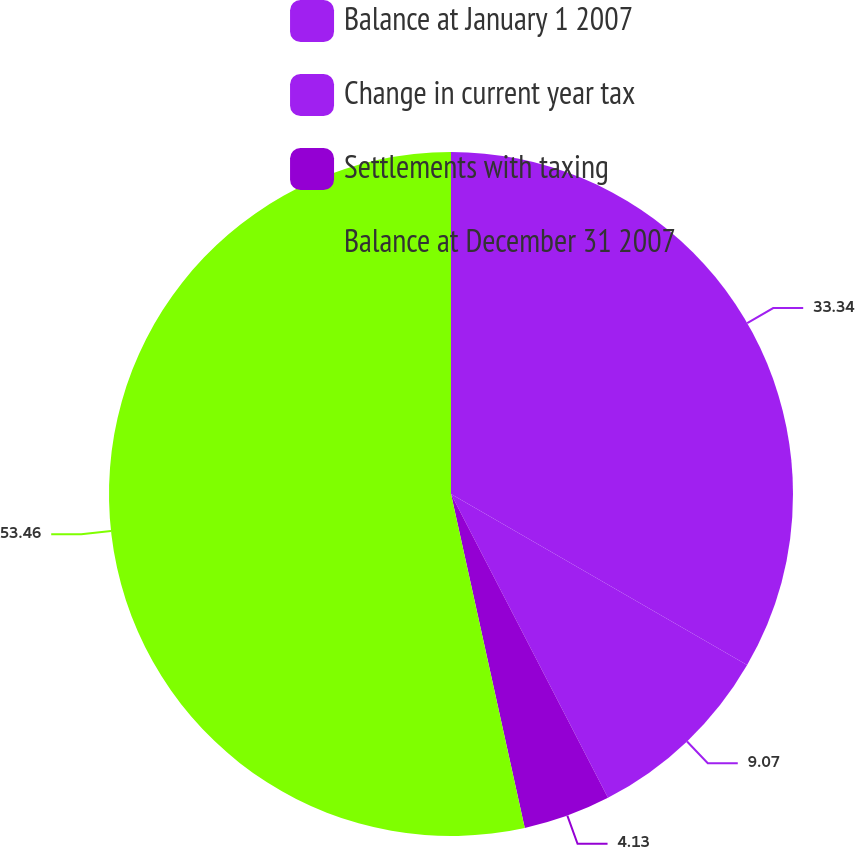Convert chart. <chart><loc_0><loc_0><loc_500><loc_500><pie_chart><fcel>Balance at January 1 2007<fcel>Change in current year tax<fcel>Settlements with taxing<fcel>Balance at December 31 2007<nl><fcel>33.34%<fcel>9.07%<fcel>4.13%<fcel>53.46%<nl></chart> 